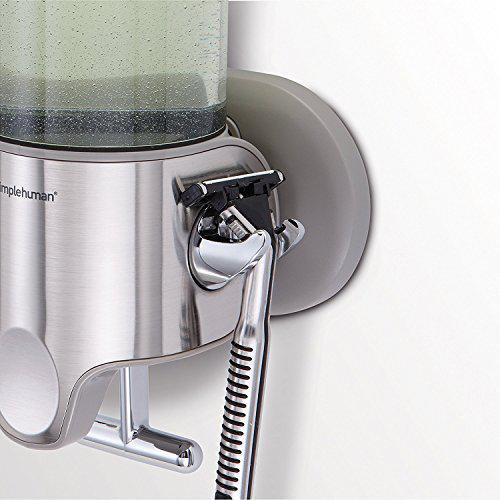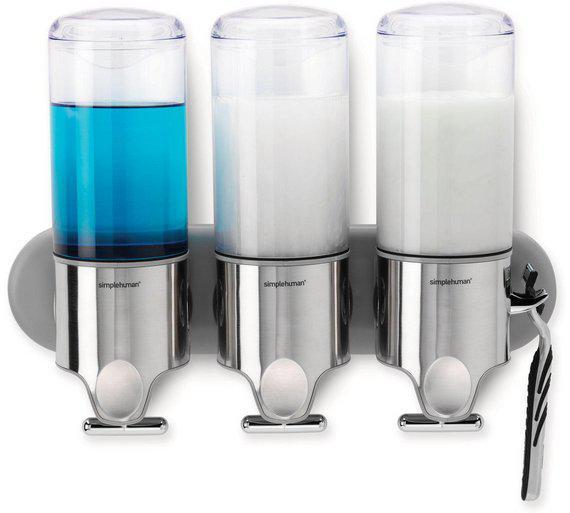The first image is the image on the left, the second image is the image on the right. Considering the images on both sides, is "Both the top and bottom of three dispensers are made from shiny metallic material." valid? Answer yes or no. No. 